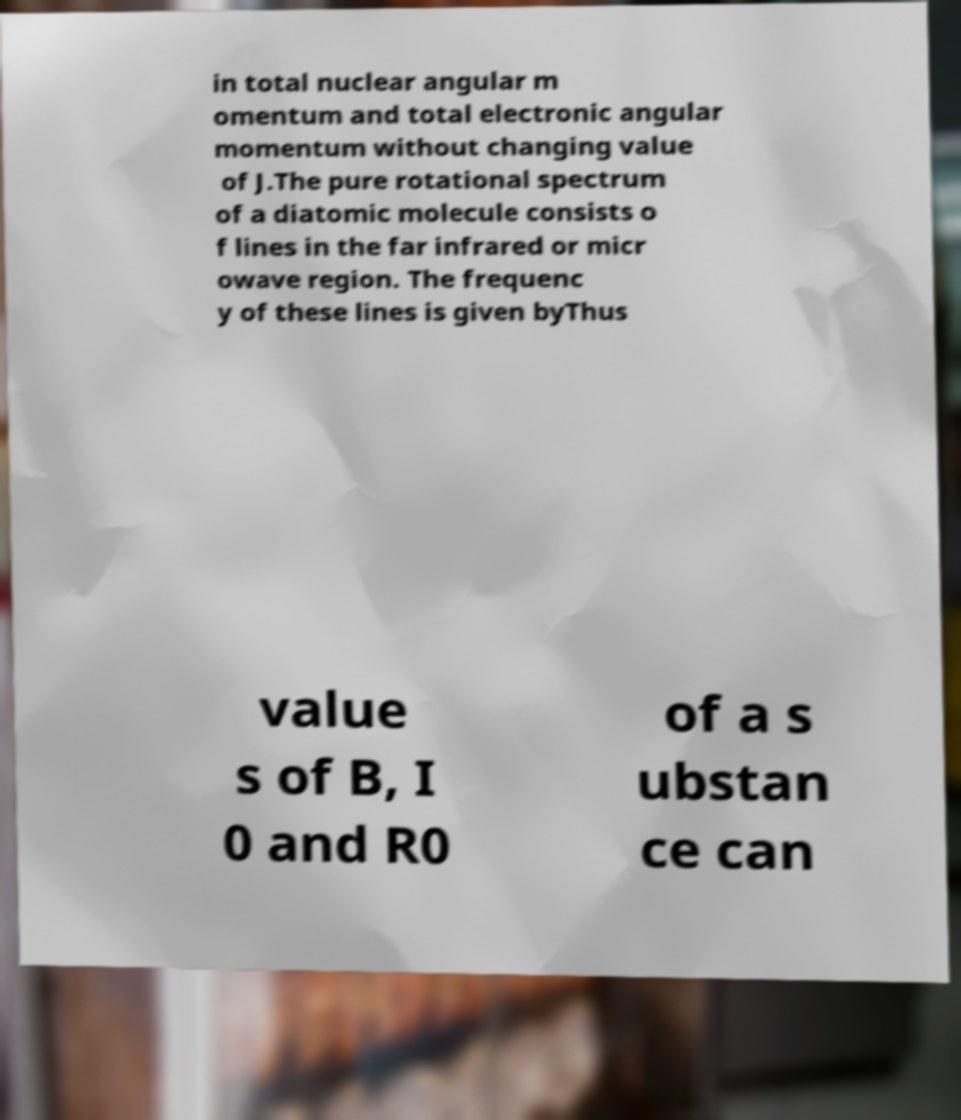There's text embedded in this image that I need extracted. Can you transcribe it verbatim? in total nuclear angular m omentum and total electronic angular momentum without changing value of J.The pure rotational spectrum of a diatomic molecule consists o f lines in the far infrared or micr owave region. The frequenc y of these lines is given byThus value s of B, I 0 and R0 of a s ubstan ce can 